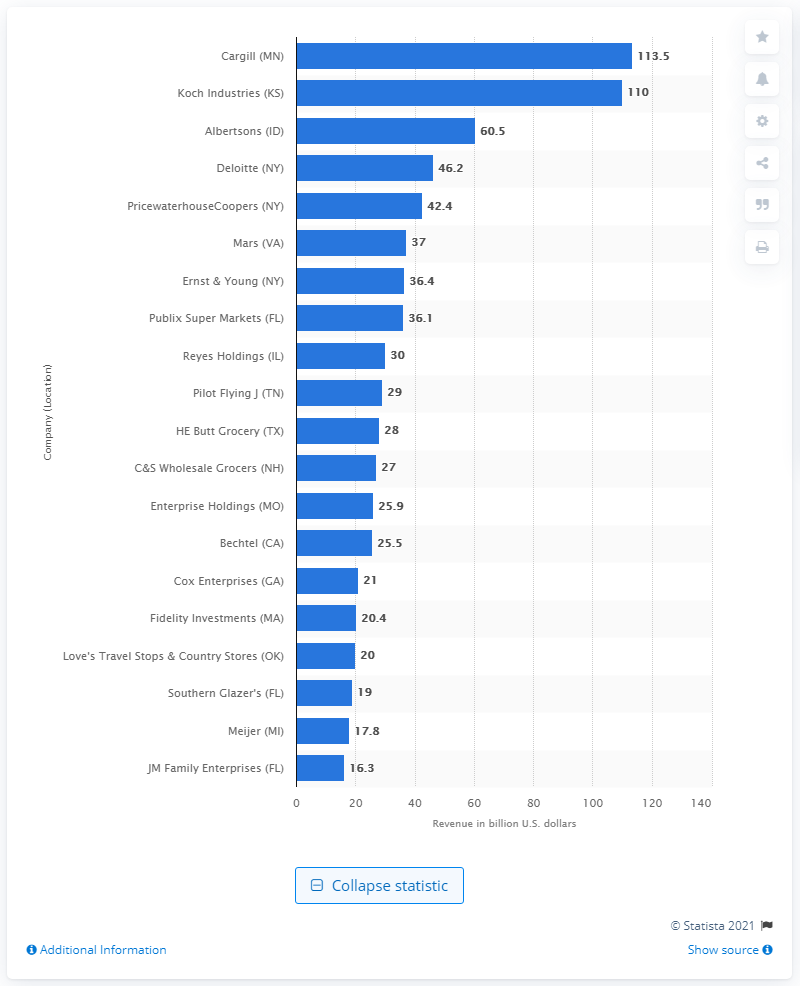Point out several critical features in this image. JM Family Enterprises made approximately $16.3 billion in dollars in 2019. Cargill's revenue in 2019 was $113.5 billion. 